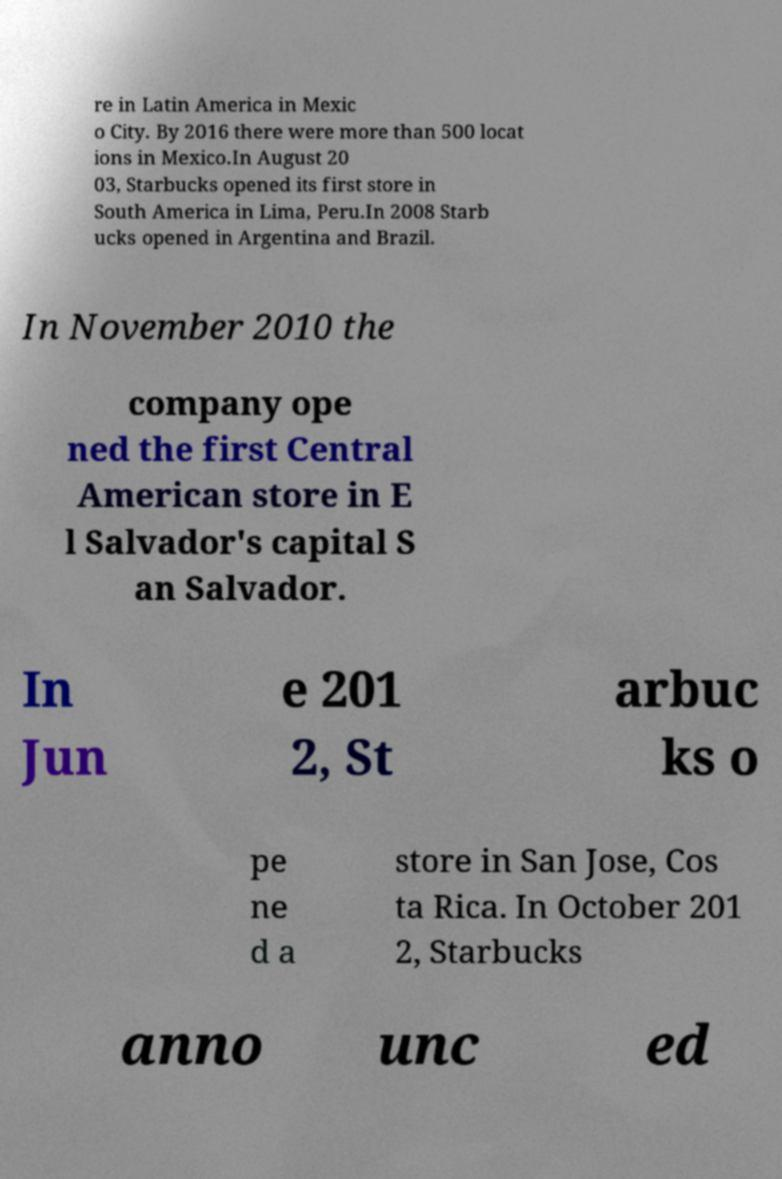For documentation purposes, I need the text within this image transcribed. Could you provide that? re in Latin America in Mexic o City. By 2016 there were more than 500 locat ions in Mexico.In August 20 03, Starbucks opened its first store in South America in Lima, Peru.In 2008 Starb ucks opened in Argentina and Brazil. In November 2010 the company ope ned the first Central American store in E l Salvador's capital S an Salvador. In Jun e 201 2, St arbuc ks o pe ne d a store in San Jose, Cos ta Rica. In October 201 2, Starbucks anno unc ed 